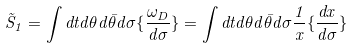<formula> <loc_0><loc_0><loc_500><loc_500>\tilde { S } _ { 1 } = \int d t d \theta d \bar { \theta } d \sigma \{ \frac { \omega _ { D } } { d \sigma } \} = \int d t d \theta d \bar { \theta } d \sigma \frac { 1 } { x } \{ \frac { d x } { d \sigma } \}</formula> 